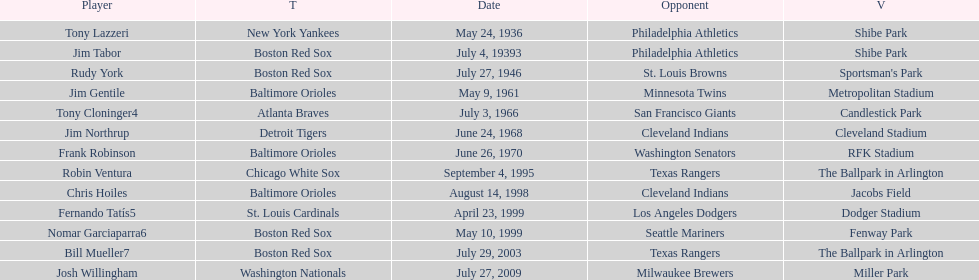Which teams faced off at miller park? Washington Nationals, Milwaukee Brewers. 